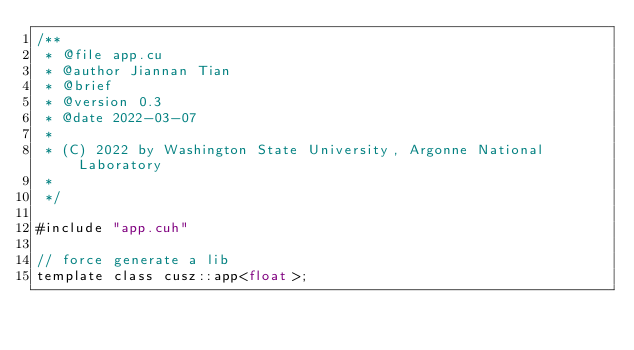<code> <loc_0><loc_0><loc_500><loc_500><_Cuda_>/**
 * @file app.cu
 * @author Jiannan Tian
 * @brief
 * @version 0.3
 * @date 2022-03-07
 *
 * (C) 2022 by Washington State University, Argonne National Laboratory
 *
 */

#include "app.cuh"

// force generate a lib
template class cusz::app<float>;</code> 